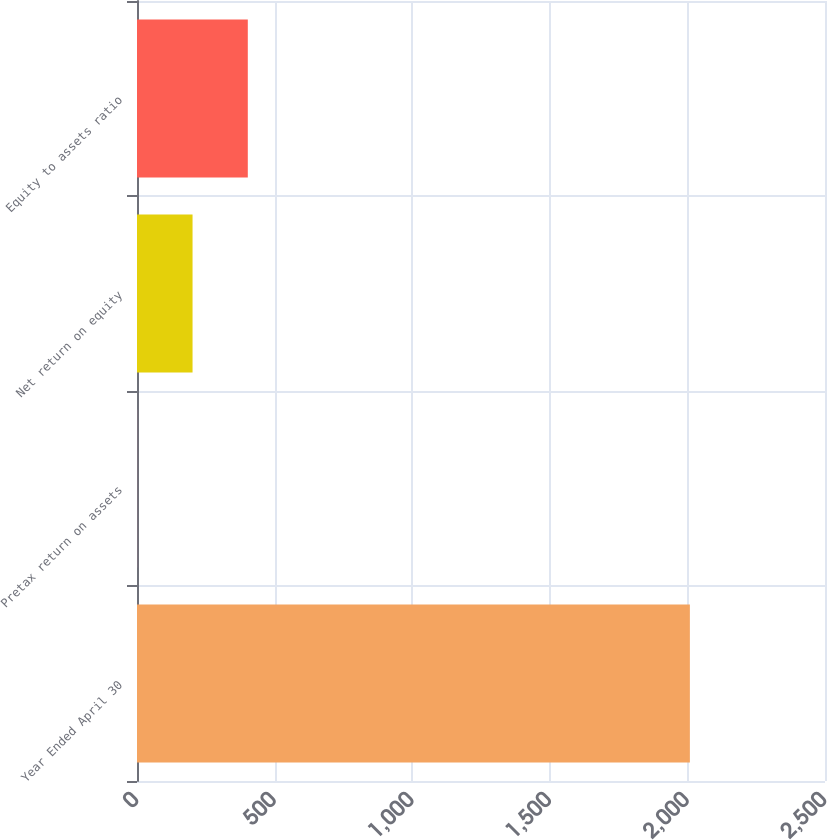<chart> <loc_0><loc_0><loc_500><loc_500><bar_chart><fcel>Year Ended April 30<fcel>Pretax return on assets<fcel>Net return on equity<fcel>Equity to assets ratio<nl><fcel>2009<fcel>1.03<fcel>201.83<fcel>402.63<nl></chart> 